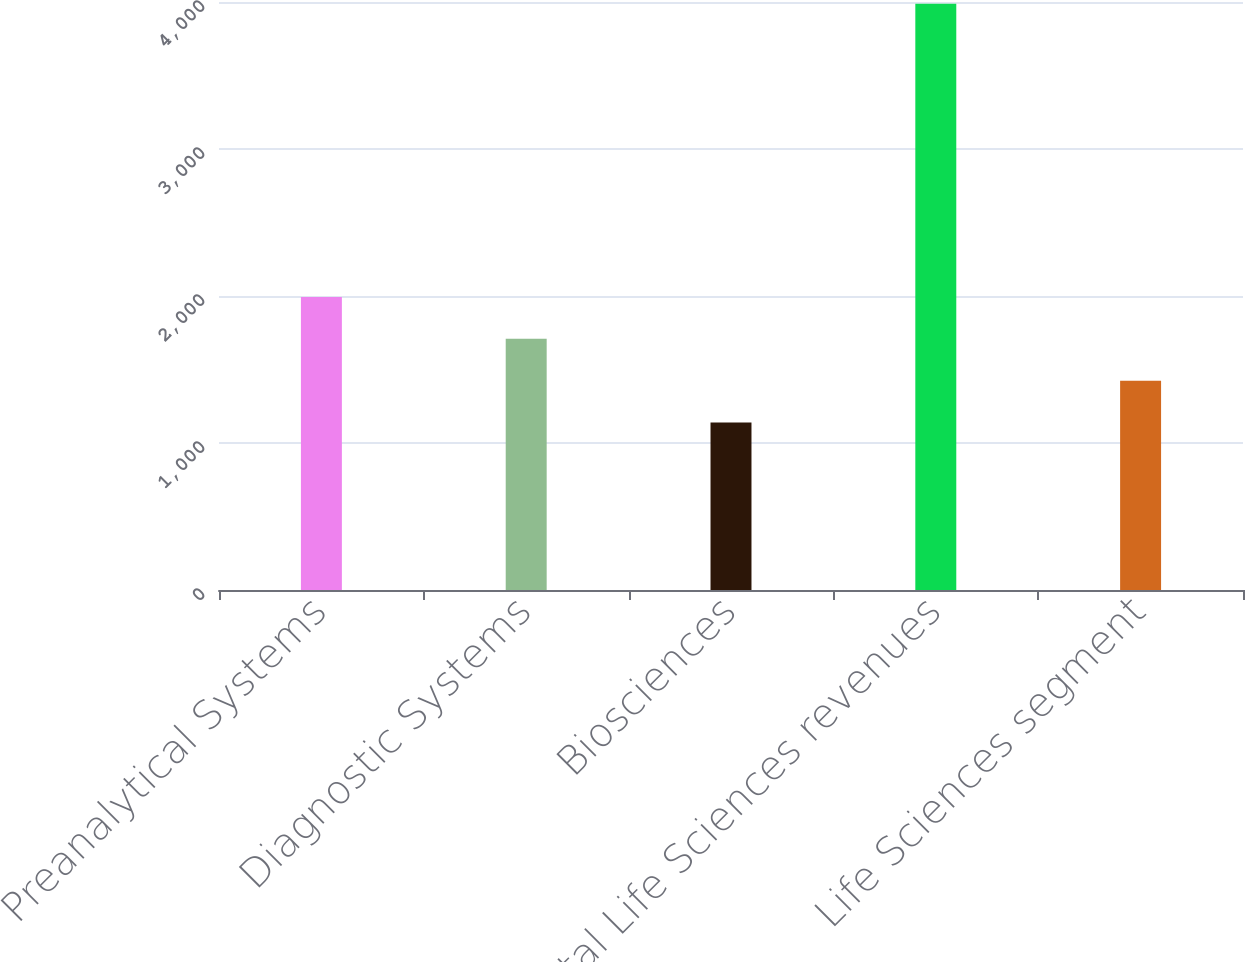Convert chart. <chart><loc_0><loc_0><loc_500><loc_500><bar_chart><fcel>Preanalytical Systems<fcel>Diagnostic Systems<fcel>Biosciences<fcel>Total Life Sciences revenues<fcel>Life Sciences segment<nl><fcel>1993.7<fcel>1708.8<fcel>1139<fcel>3988<fcel>1423.9<nl></chart> 